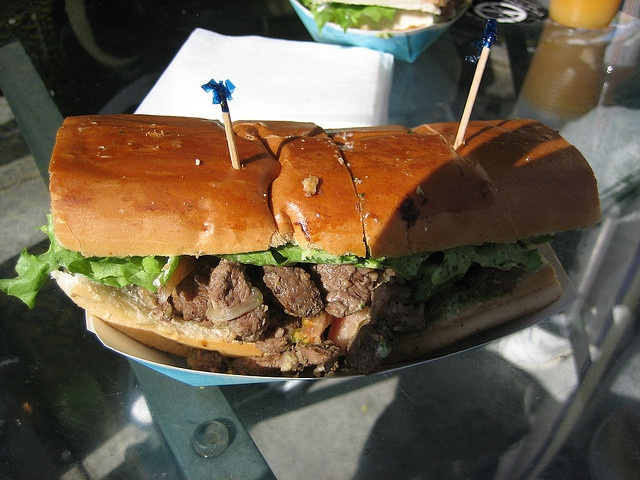Describe the objects in this image and their specific colors. I can see dining table in black, gray, white, and brown tones, sandwich in black, brown, maroon, and tan tones, and cup in black, orange, and olive tones in this image. 